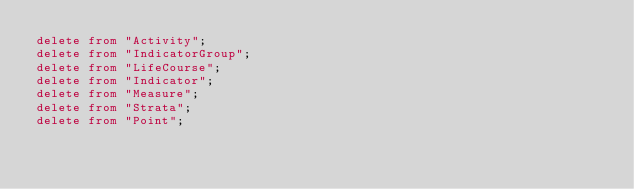Convert code to text. <code><loc_0><loc_0><loc_500><loc_500><_SQL_>delete from "Activity";
delete from "IndicatorGroup";
delete from "LifeCourse";
delete from "Indicator";
delete from "Measure";
delete from "Strata";
delete from "Point";
</code> 